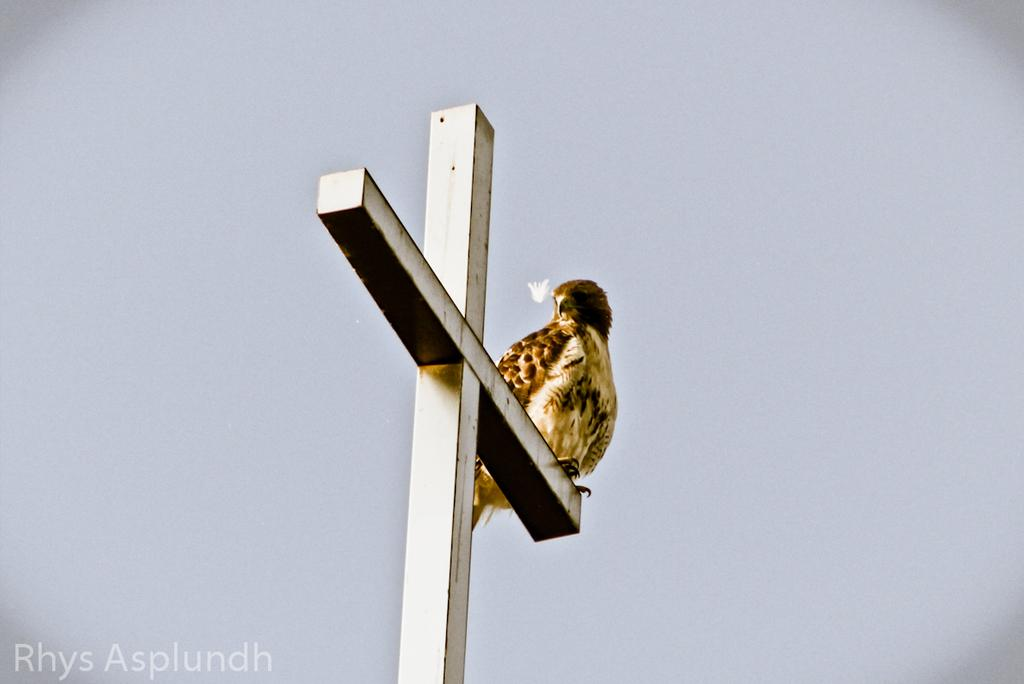What type of animal is in the image? There is a bird in the image. Where is the bird located? The bird is on a pole. What does the pole resemble? The pole resembles a crucifix. What can be seen in the background of the image? The sky is visible in the background of the image. What type of skirt is the bird wearing in the image? There is no skirt present in the image, as birds do not wear clothing. 